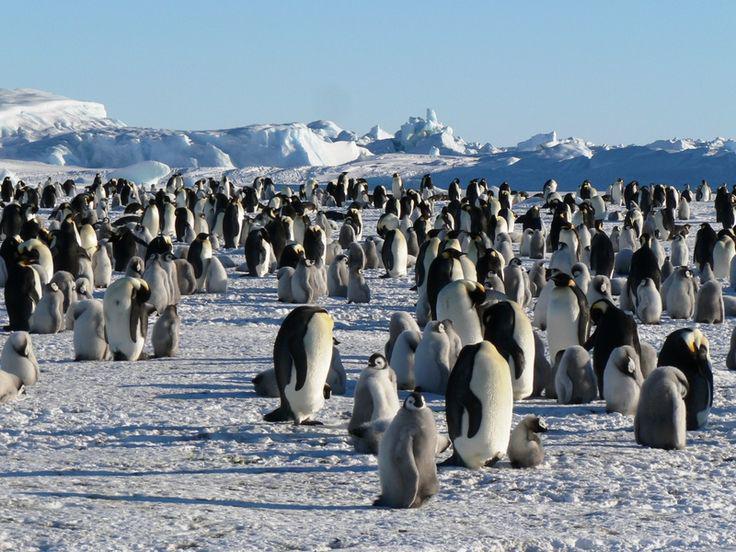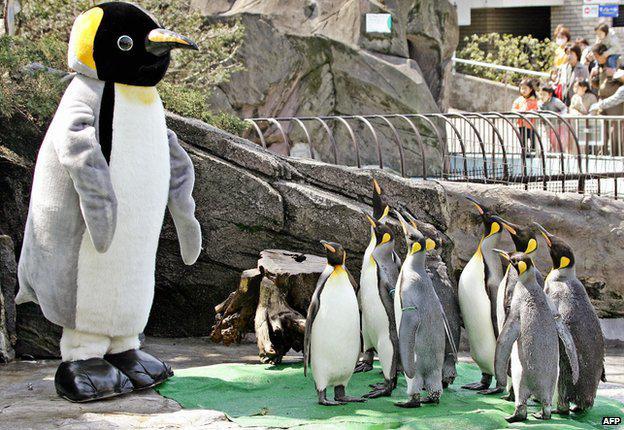The first image is the image on the left, the second image is the image on the right. Assess this claim about the two images: "One camera is attached to a tripod that's resting on the ground.". Correct or not? Answer yes or no. No. The first image is the image on the left, the second image is the image on the right. Evaluate the accuracy of this statement regarding the images: "An image includes at least one penguin and a person behind a scope on a tripod.". Is it true? Answer yes or no. No. 